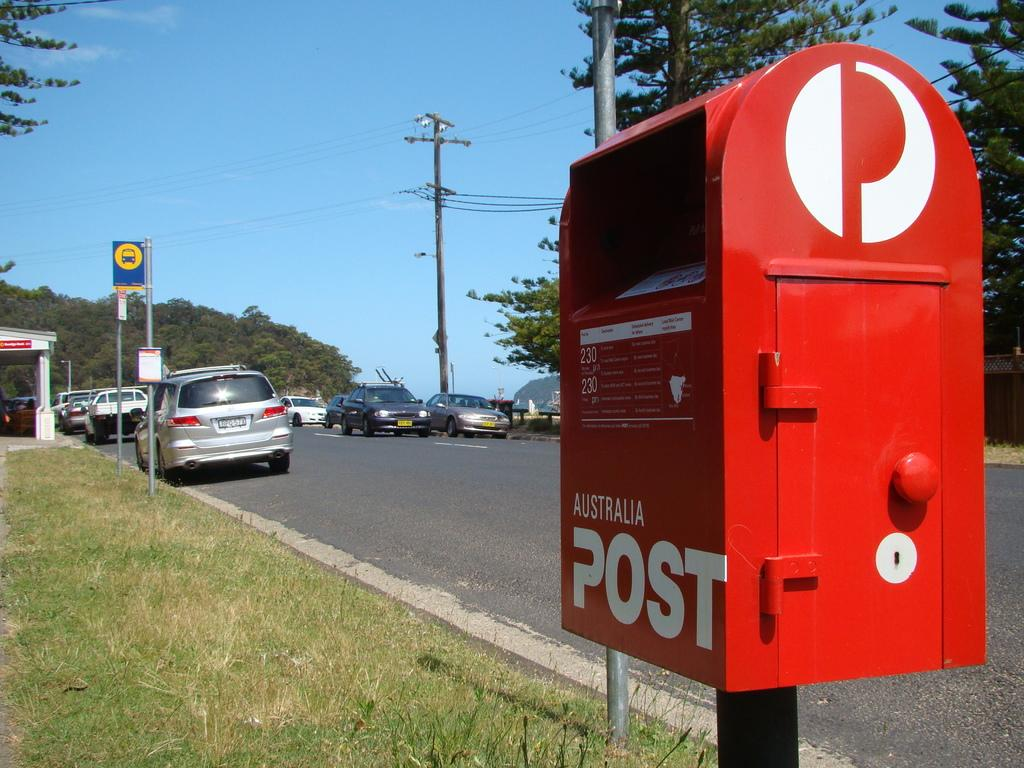What object is used for mailing purposes in the image? There is a postbox in the image. What type of vegetation can be seen in the image? There is grass visible in the image. What type of vehicles are present in the image? There are cars in the image. What type of infrastructure is present in the image? There is a current pole in the image. What other natural elements can be seen in the image? There are trees in the image. What is visible in the background of the image? The sky is visible in the image. How many pigs are playing with the key in the tree in the image? There are no pigs or keys present in the image, and no tree is mentioned in the provided facts. 